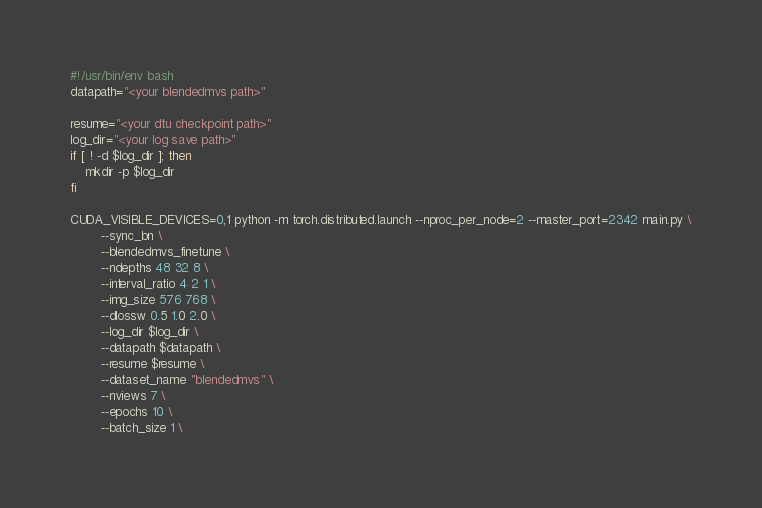Convert code to text. <code><loc_0><loc_0><loc_500><loc_500><_Bash_>#!/usr/bin/env bash
datapath="<your blendedmvs path>"

resume="<your dtu checkpoint path>"
log_dir="<your log save path>"
if [ ! -d $log_dir ]; then
    mkdir -p $log_dir
fi

CUDA_VISIBLE_DEVICES=0,1 python -m torch.distributed.launch --nproc_per_node=2 --master_port=2342 main.py \
        --sync_bn \
        --blendedmvs_finetune \
        --ndepths 48 32 8 \
        --interval_ratio 4 2 1 \
        --img_size 576 768 \
        --dlossw 0.5 1.0 2.0 \
        --log_dir $log_dir \
        --datapath $datapath \
        --resume $resume \
        --dataset_name "blendedmvs" \
        --nviews 7 \
        --epochs 10 \
        --batch_size 1 \</code> 